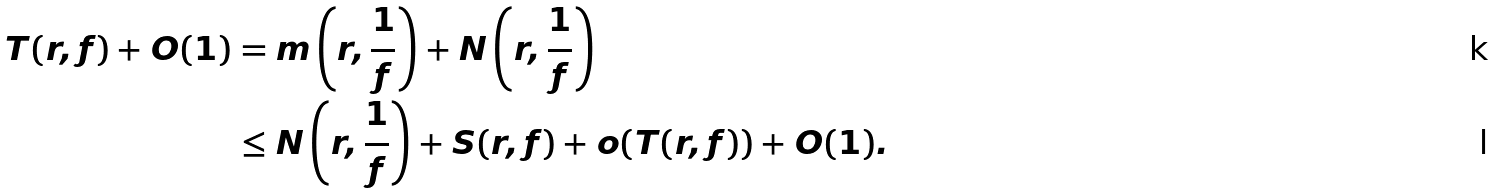Convert formula to latex. <formula><loc_0><loc_0><loc_500><loc_500>T ( r , f ) + O ( 1 ) & = m \left ( r , \frac { 1 } { f } \right ) + N \left ( r , \frac { 1 } { f } \right ) \\ & \leq N \left ( r , \frac { 1 } { f } \right ) + S ( r , f ) + o ( T ( r , f ) ) + O ( 1 ) .</formula> 